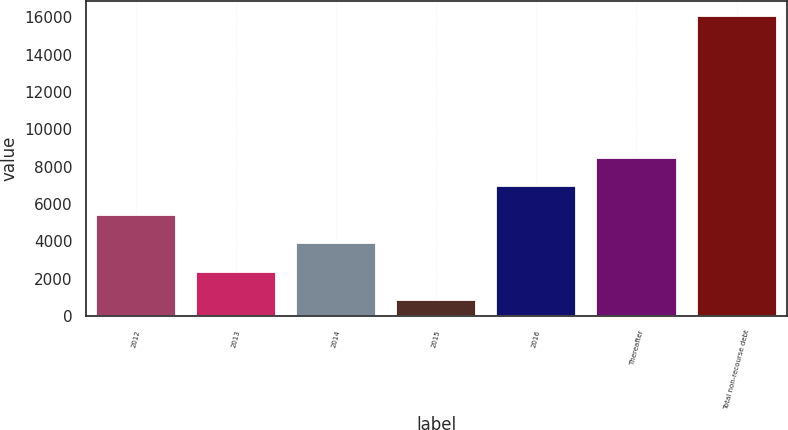Convert chart. <chart><loc_0><loc_0><loc_500><loc_500><bar_chart><fcel>2012<fcel>2013<fcel>2014<fcel>2015<fcel>2016<fcel>Thereafter<fcel>Total non-recourse debt<nl><fcel>5422.1<fcel>2374.7<fcel>3898.4<fcel>851<fcel>6945.8<fcel>8469.5<fcel>16088<nl></chart> 